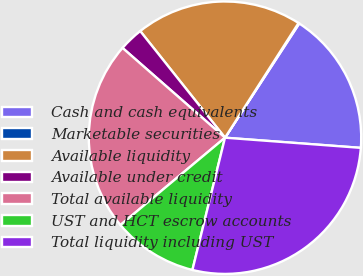<chart> <loc_0><loc_0><loc_500><loc_500><pie_chart><fcel>Cash and cash equivalents<fcel>Marketable securities<fcel>Available liquidity<fcel>Available under credit<fcel>Total available liquidity<fcel>UST and HCT escrow accounts<fcel>Total liquidity including UST<nl><fcel>17.02%<fcel>0.1%<fcel>19.77%<fcel>2.86%<fcel>22.53%<fcel>10.08%<fcel>27.66%<nl></chart> 